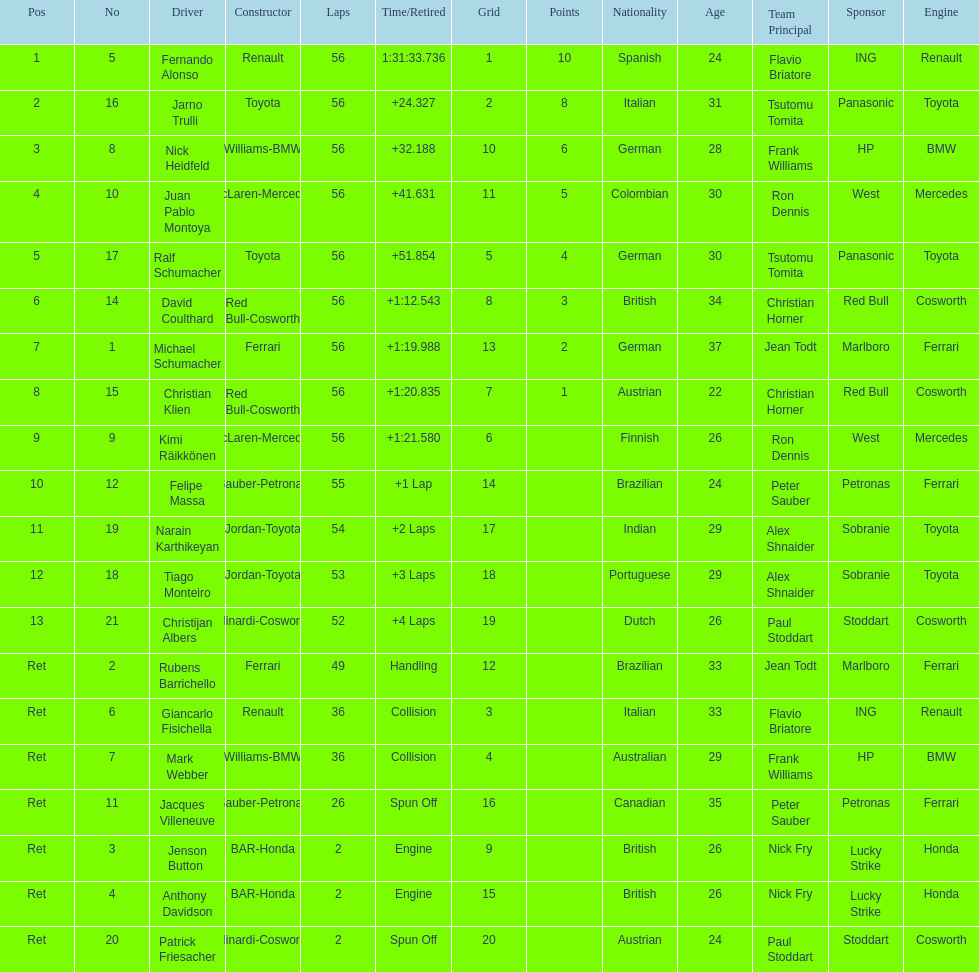Who finished before nick heidfeld? Jarno Trulli. 